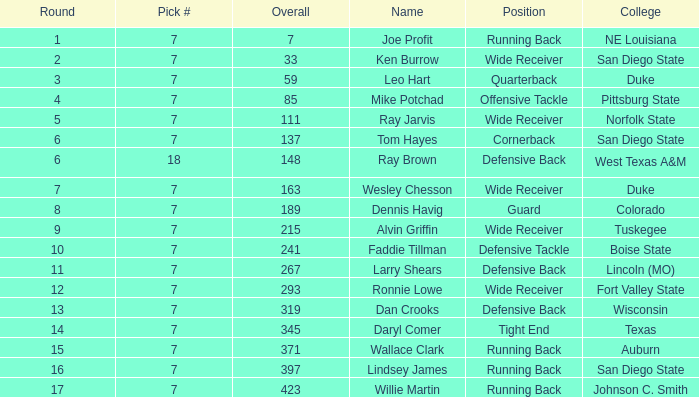Can you give me this table as a dict? {'header': ['Round', 'Pick #', 'Overall', 'Name', 'Position', 'College'], 'rows': [['1', '7', '7', 'Joe Profit', 'Running Back', 'NE Louisiana'], ['2', '7', '33', 'Ken Burrow', 'Wide Receiver', 'San Diego State'], ['3', '7', '59', 'Leo Hart', 'Quarterback', 'Duke'], ['4', '7', '85', 'Mike Potchad', 'Offensive Tackle', 'Pittsburg State'], ['5', '7', '111', 'Ray Jarvis', 'Wide Receiver', 'Norfolk State'], ['6', '7', '137', 'Tom Hayes', 'Cornerback', 'San Diego State'], ['6', '18', '148', 'Ray Brown', 'Defensive Back', 'West Texas A&M'], ['7', '7', '163', 'Wesley Chesson', 'Wide Receiver', 'Duke'], ['8', '7', '189', 'Dennis Havig', 'Guard', 'Colorado'], ['9', '7', '215', 'Alvin Griffin', 'Wide Receiver', 'Tuskegee'], ['10', '7', '241', 'Faddie Tillman', 'Defensive Tackle', 'Boise State'], ['11', '7', '267', 'Larry Shears', 'Defensive Back', 'Lincoln (MO)'], ['12', '7', '293', 'Ronnie Lowe', 'Wide Receiver', 'Fort Valley State'], ['13', '7', '319', 'Dan Crooks', 'Defensive Back', 'Wisconsin'], ['14', '7', '345', 'Daryl Comer', 'Tight End', 'Texas'], ['15', '7', '371', 'Wallace Clark', 'Running Back', 'Auburn'], ['16', '7', '397', 'Lindsey James', 'Running Back', 'San Diego State'], ['17', '7', '423', 'Willie Martin', 'Running Back', 'Johnson C. Smith']]} At what draft position was the player from texas chosen? 1.0. 